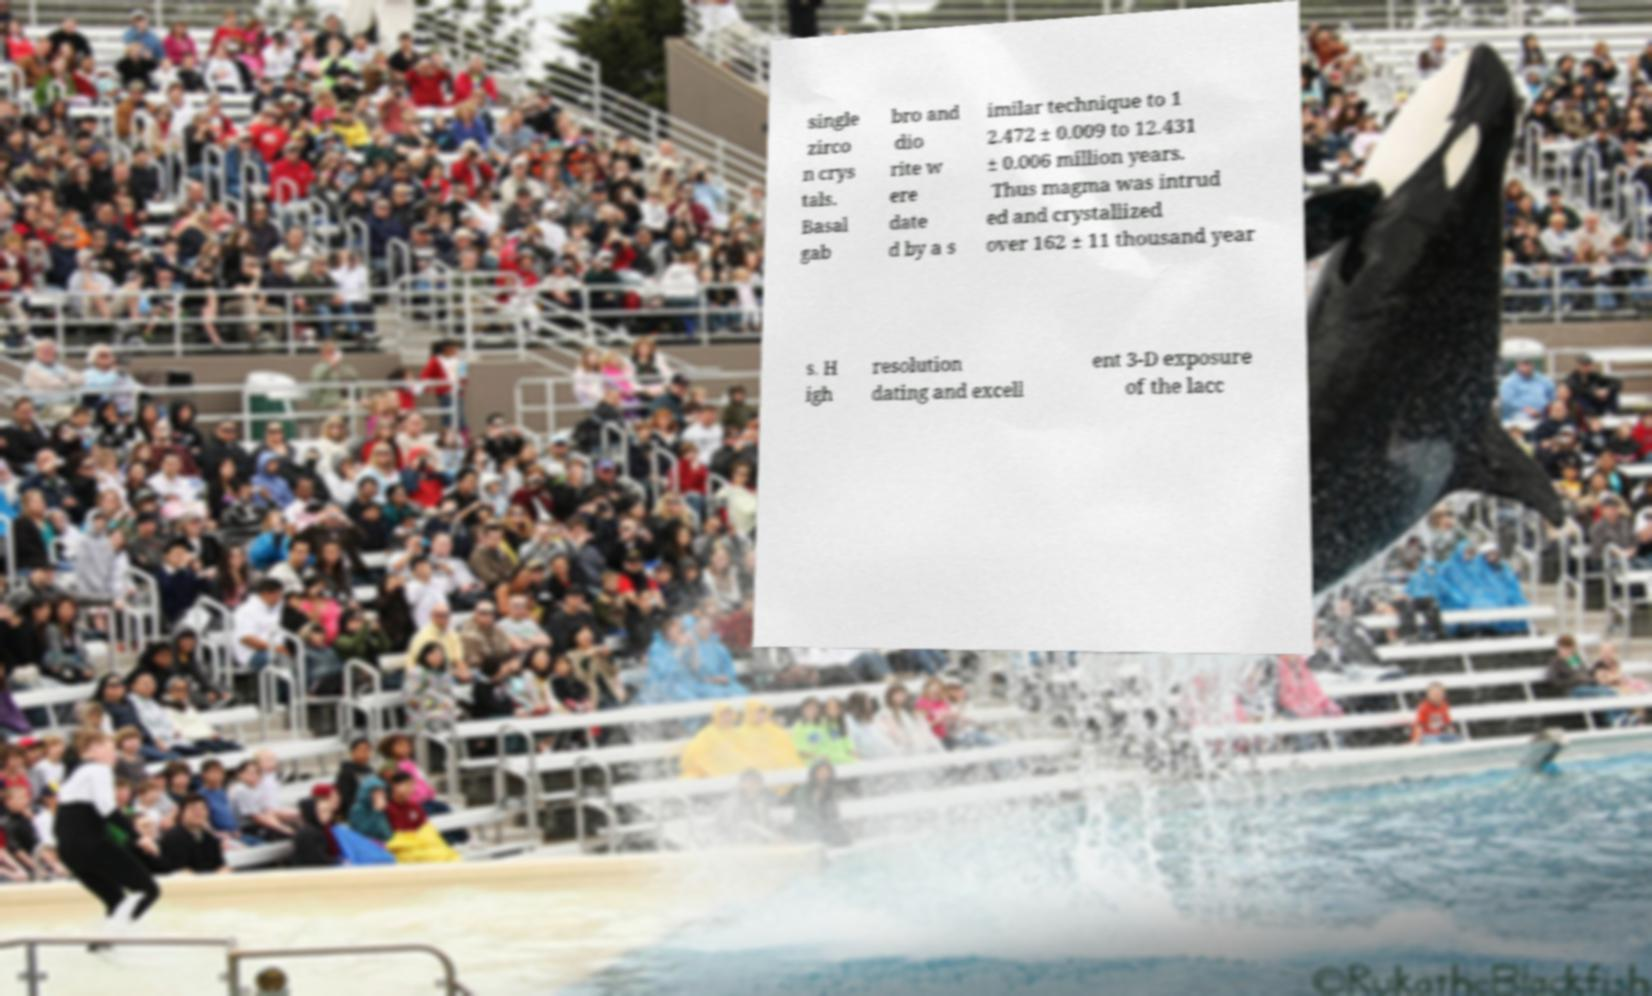Please read and relay the text visible in this image. What does it say? single zirco n crys tals. Basal gab bro and dio rite w ere date d by a s imilar technique to 1 2.472 ± 0.009 to 12.431 ± 0.006 million years. Thus magma was intrud ed and crystallized over 162 ± 11 thousand year s. H igh resolution dating and excell ent 3-D exposure of the lacc 